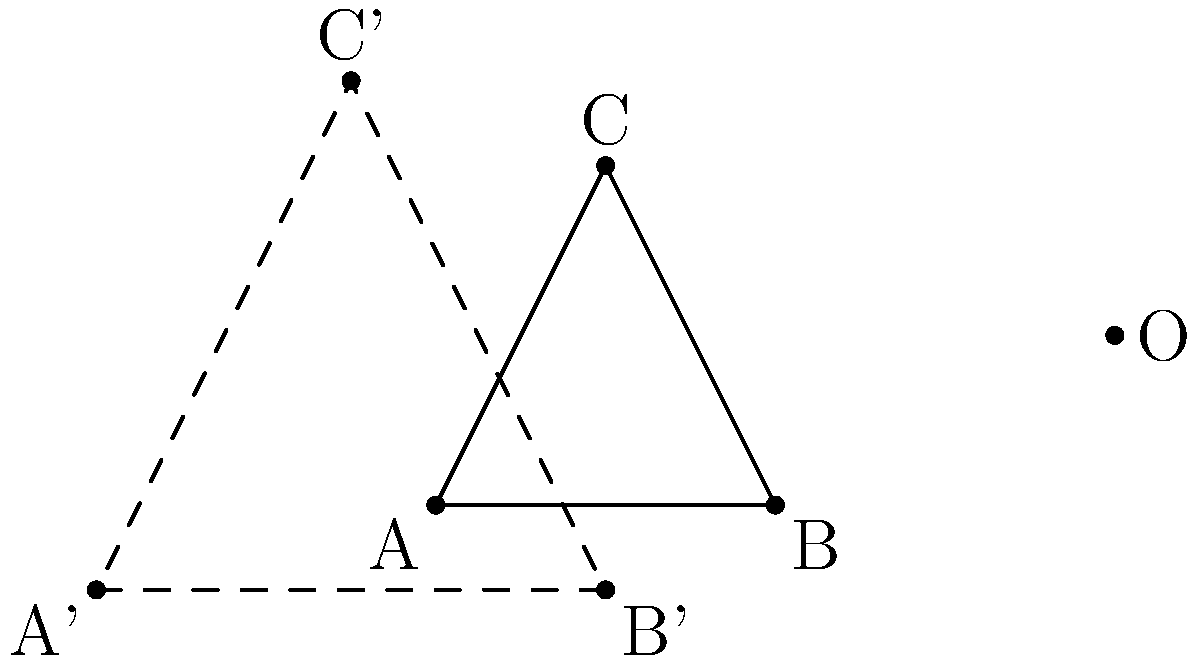A molecular structure diagram of a low-calorie beer ingredient is represented by triangle ABC. If this structure is dilated by a scale factor of 1.5 with center O, what is the area of the resulting triangle A'B'C' in terms of the area of the original triangle ABC? Let's approach this step-by-step:

1) In a dilation, the shape of the figure remains the same, but its size changes according to the scale factor.

2) The scale factor here is 1.5, which means that all linear dimensions (sides, heights) of the new triangle will be 1.5 times those of the original triangle.

3) The area of a triangle is given by the formula: $A = \frac{1}{2} \times base \times height$

4) If both the base and height are multiplied by 1.5, the new area will be:

   $A' = \frac{1}{2} \times (1.5 \times base) \times (1.5 \times height)$

5) This can be rewritten as:

   $A' = \frac{1}{2} \times 1.5^2 \times base \times height = 1.5^2 \times (\frac{1}{2} \times base \times height)$

6) The term in parentheses is the area of the original triangle, so:

   $A' = 1.5^2 \times A = 2.25A$

Therefore, the area of the new triangle A'B'C' is 2.25 times the area of the original triangle ABC.
Answer: $2.25A$ 